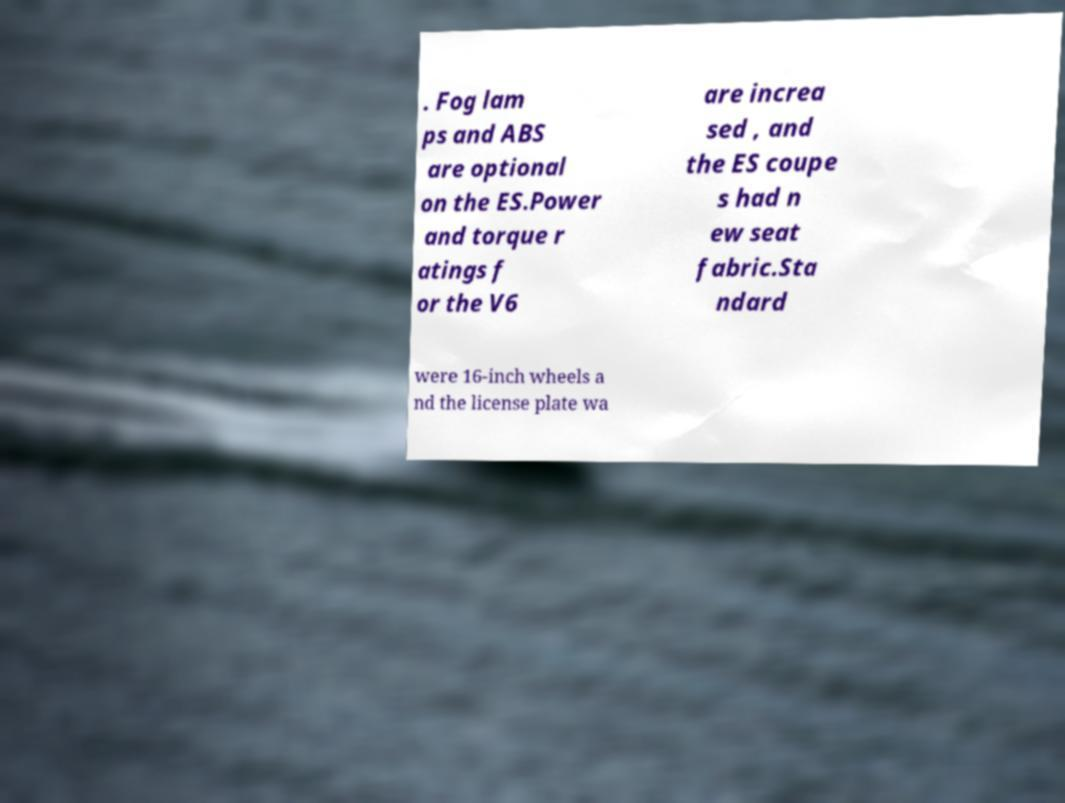What messages or text are displayed in this image? I need them in a readable, typed format. . Fog lam ps and ABS are optional on the ES.Power and torque r atings f or the V6 are increa sed , and the ES coupe s had n ew seat fabric.Sta ndard were 16-inch wheels a nd the license plate wa 